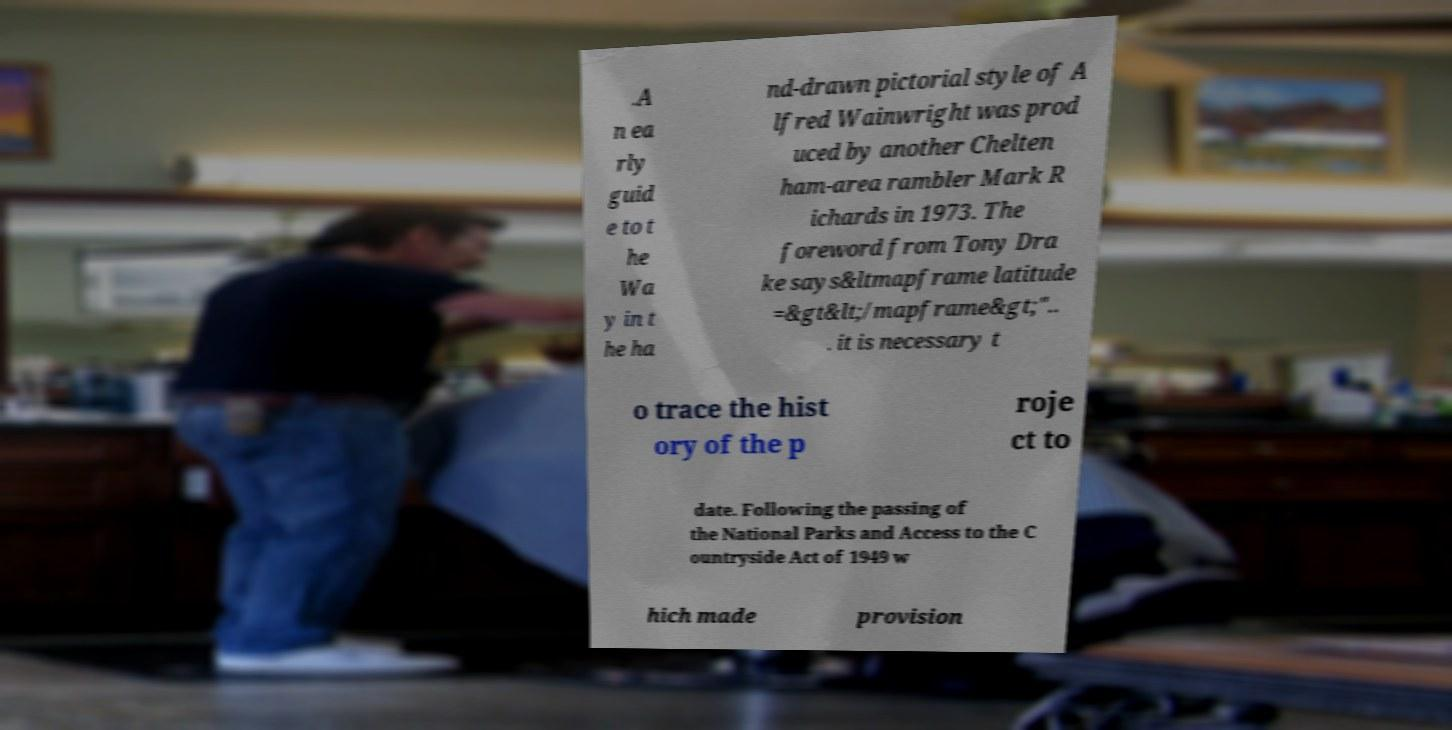Can you accurately transcribe the text from the provided image for me? .A n ea rly guid e to t he Wa y in t he ha nd-drawn pictorial style of A lfred Wainwright was prod uced by another Chelten ham-area rambler Mark R ichards in 1973. The foreword from Tony Dra ke says&ltmapframe latitude =&gt&lt;/mapframe&gt;".. . it is necessary t o trace the hist ory of the p roje ct to date. Following the passing of the National Parks and Access to the C ountryside Act of 1949 w hich made provision 